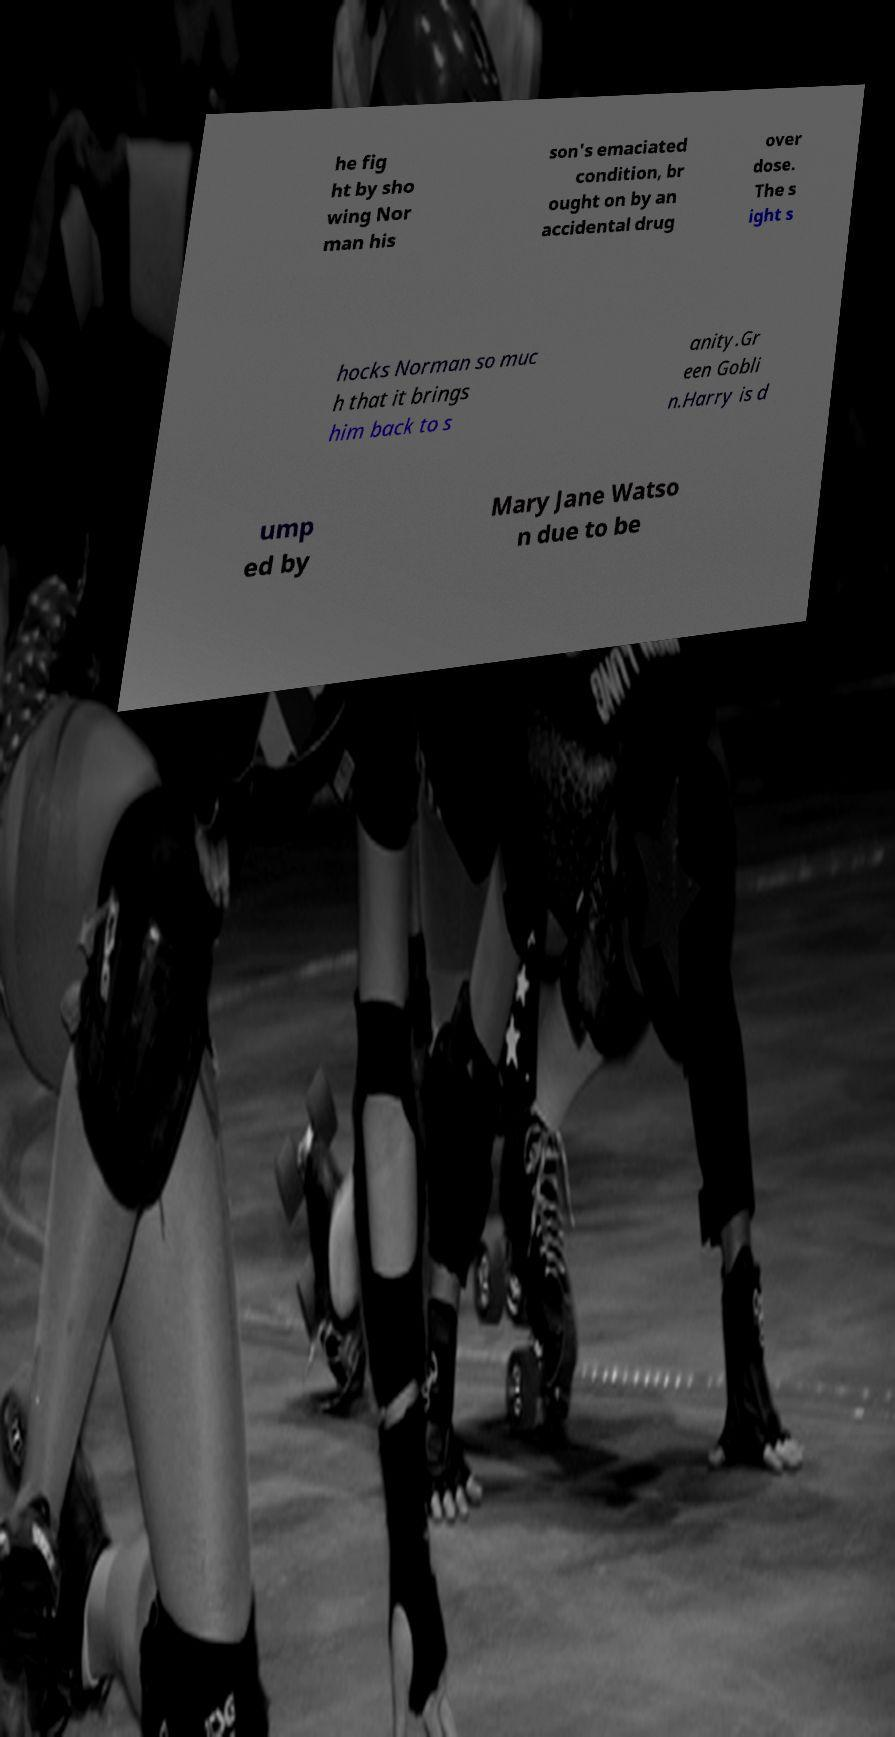For documentation purposes, I need the text within this image transcribed. Could you provide that? he fig ht by sho wing Nor man his son's emaciated condition, br ought on by an accidental drug over dose. The s ight s hocks Norman so muc h that it brings him back to s anity.Gr een Gobli n.Harry is d ump ed by Mary Jane Watso n due to be 